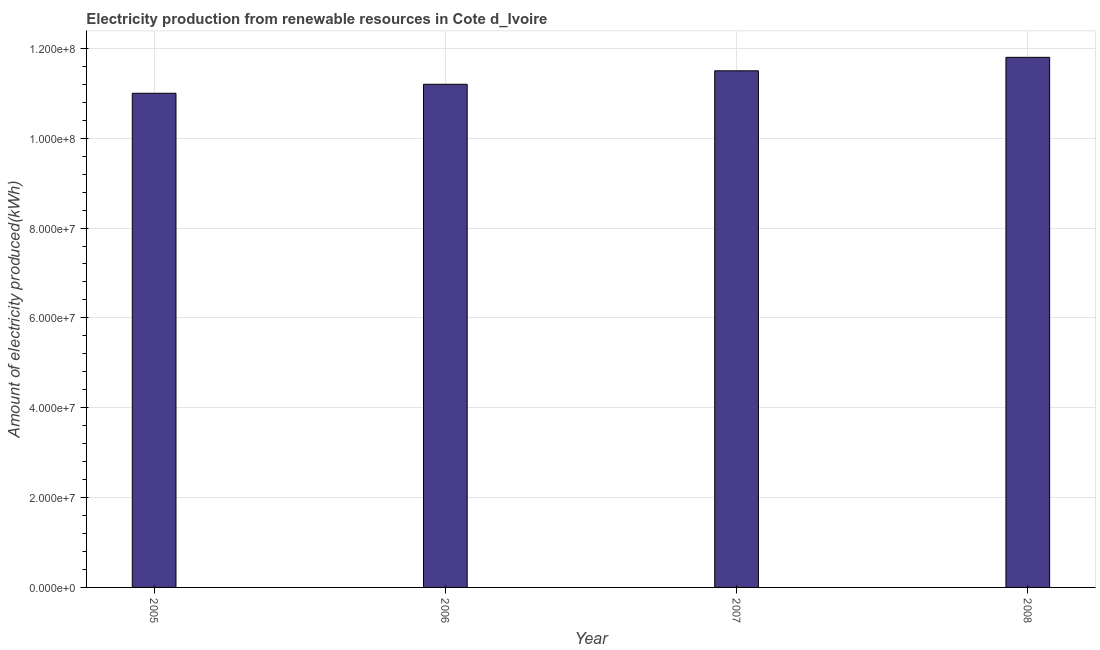What is the title of the graph?
Your response must be concise. Electricity production from renewable resources in Cote d_Ivoire. What is the label or title of the Y-axis?
Offer a terse response. Amount of electricity produced(kWh). What is the amount of electricity produced in 2006?
Provide a short and direct response. 1.12e+08. Across all years, what is the maximum amount of electricity produced?
Provide a short and direct response. 1.18e+08. Across all years, what is the minimum amount of electricity produced?
Offer a terse response. 1.10e+08. In which year was the amount of electricity produced maximum?
Offer a terse response. 2008. What is the sum of the amount of electricity produced?
Your answer should be compact. 4.55e+08. What is the difference between the amount of electricity produced in 2005 and 2008?
Your answer should be compact. -8.00e+06. What is the average amount of electricity produced per year?
Make the answer very short. 1.14e+08. What is the median amount of electricity produced?
Provide a succinct answer. 1.14e+08. In how many years, is the amount of electricity produced greater than 68000000 kWh?
Your answer should be very brief. 4. What is the ratio of the amount of electricity produced in 2007 to that in 2008?
Your response must be concise. 0.97. Is the sum of the amount of electricity produced in 2007 and 2008 greater than the maximum amount of electricity produced across all years?
Offer a terse response. Yes. What is the difference between the highest and the lowest amount of electricity produced?
Offer a very short reply. 8.00e+06. In how many years, is the amount of electricity produced greater than the average amount of electricity produced taken over all years?
Make the answer very short. 2. Are the values on the major ticks of Y-axis written in scientific E-notation?
Provide a short and direct response. Yes. What is the Amount of electricity produced(kWh) of 2005?
Ensure brevity in your answer.  1.10e+08. What is the Amount of electricity produced(kWh) in 2006?
Provide a short and direct response. 1.12e+08. What is the Amount of electricity produced(kWh) in 2007?
Give a very brief answer. 1.15e+08. What is the Amount of electricity produced(kWh) of 2008?
Provide a succinct answer. 1.18e+08. What is the difference between the Amount of electricity produced(kWh) in 2005 and 2006?
Provide a succinct answer. -2.00e+06. What is the difference between the Amount of electricity produced(kWh) in 2005 and 2007?
Ensure brevity in your answer.  -5.00e+06. What is the difference between the Amount of electricity produced(kWh) in 2005 and 2008?
Provide a succinct answer. -8.00e+06. What is the difference between the Amount of electricity produced(kWh) in 2006 and 2008?
Keep it short and to the point. -6.00e+06. What is the difference between the Amount of electricity produced(kWh) in 2007 and 2008?
Provide a succinct answer. -3.00e+06. What is the ratio of the Amount of electricity produced(kWh) in 2005 to that in 2008?
Your response must be concise. 0.93. What is the ratio of the Amount of electricity produced(kWh) in 2006 to that in 2008?
Offer a very short reply. 0.95. 